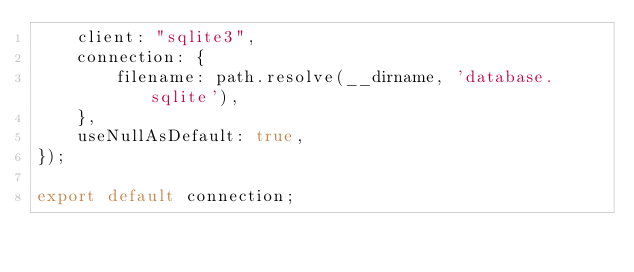Convert code to text. <code><loc_0><loc_0><loc_500><loc_500><_TypeScript_>    client: "sqlite3",
    connection: {
        filename: path.resolve(__dirname, 'database.sqlite'),
    },
    useNullAsDefault: true,
});

export default connection;</code> 